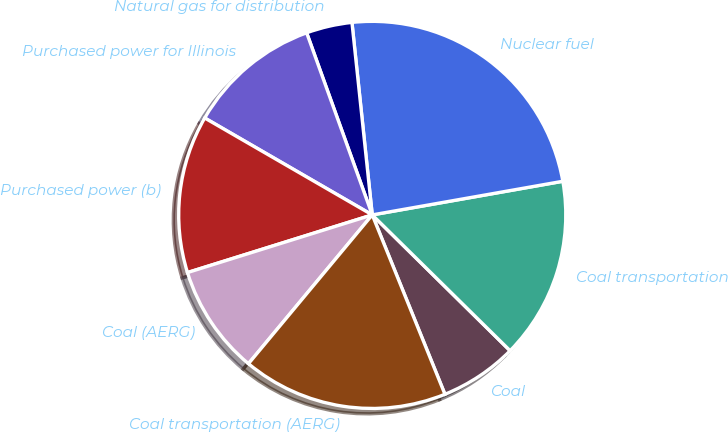Convert chart to OTSL. <chart><loc_0><loc_0><loc_500><loc_500><pie_chart><fcel>Coal<fcel>Coal transportation<fcel>Nuclear fuel<fcel>Natural gas for distribution<fcel>Purchased power for Illinois<fcel>Purchased power (b)<fcel>Coal (AERG)<fcel>Coal transportation (AERG)<nl><fcel>6.49%<fcel>15.16%<fcel>23.89%<fcel>3.83%<fcel>11.15%<fcel>13.16%<fcel>9.14%<fcel>17.17%<nl></chart> 